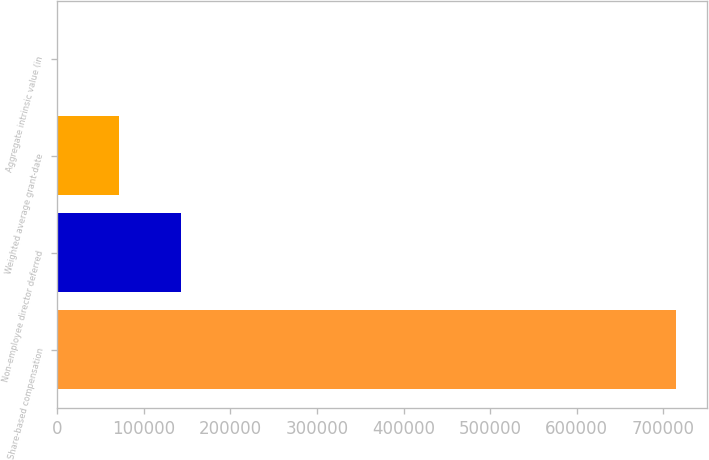<chart> <loc_0><loc_0><loc_500><loc_500><bar_chart><fcel>Share-based compensation<fcel>Non-employee director deferred<fcel>Weighted average grant-date<fcel>Aggregate intrinsic value (in<nl><fcel>715000<fcel>143000<fcel>71500.4<fcel>0.5<nl></chart> 